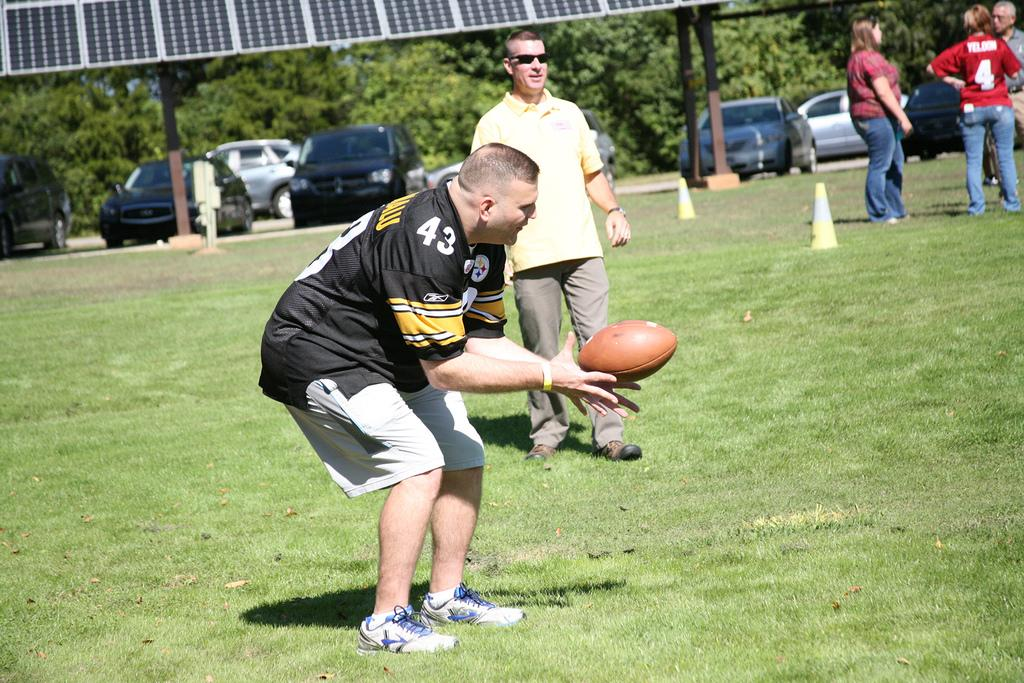<image>
Give a short and clear explanation of the subsequent image. A man wearing a black jersey with number 43 catches a football. 